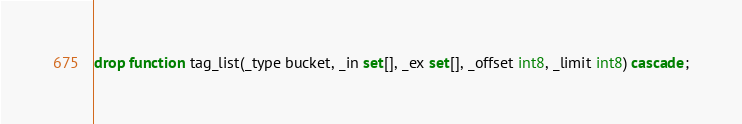Convert code to text. <code><loc_0><loc_0><loc_500><loc_500><_SQL_>drop function tag_list(_type bucket, _in set[], _ex set[], _offset int8, _limit int8) cascade;</code> 